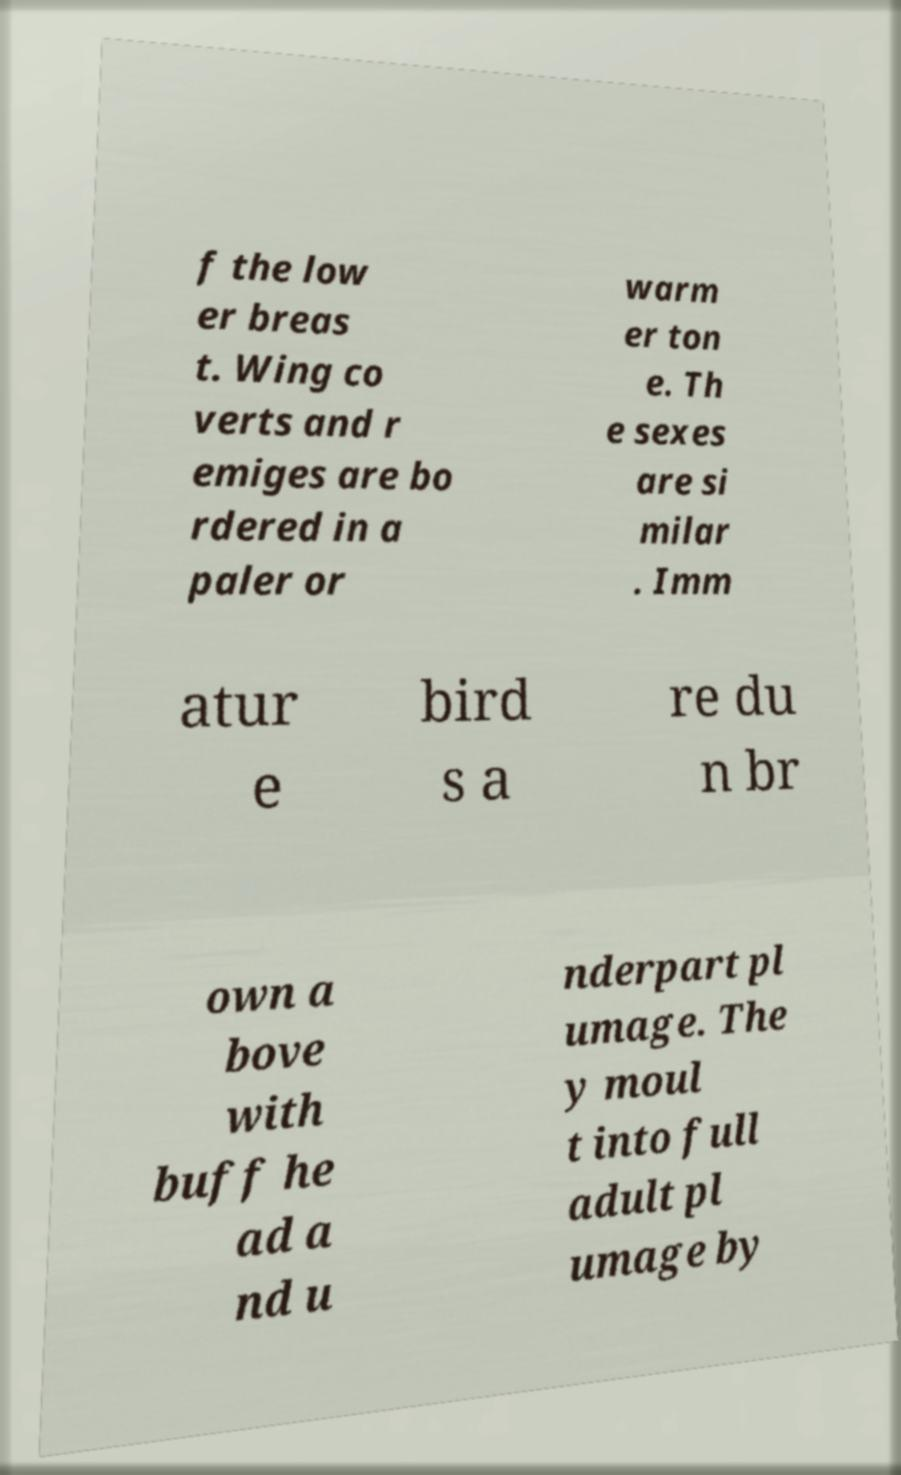Could you extract and type out the text from this image? f the low er breas t. Wing co verts and r emiges are bo rdered in a paler or warm er ton e. Th e sexes are si milar . Imm atur e bird s a re du n br own a bove with buff he ad a nd u nderpart pl umage. The y moul t into full adult pl umage by 